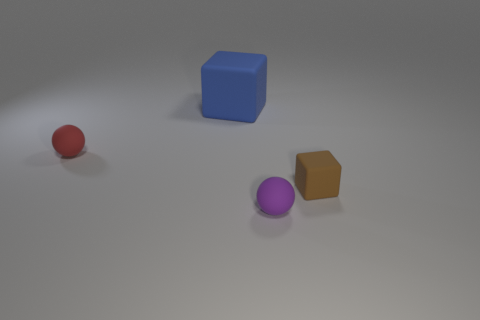Is there any other thing that is the same size as the blue rubber thing?
Make the answer very short. No. Are there any other brown things that have the same shape as the big rubber object?
Ensure brevity in your answer.  Yes. There is a sphere in front of the red rubber object; what is its size?
Offer a terse response. Small. Are there more things than blue matte blocks?
Your answer should be compact. Yes. What is the size of the cube behind the tiny object that is to the left of the large blue rubber object?
Offer a terse response. Large. What shape is the purple rubber object that is the same size as the red rubber object?
Make the answer very short. Sphere. What shape is the matte object to the right of the rubber ball in front of the small ball that is behind the tiny brown object?
Your answer should be very brief. Cube. Is the color of the cube that is to the right of the purple ball the same as the small rubber sphere that is in front of the tiny red sphere?
Your answer should be very brief. No. What number of blue rubber cubes are there?
Your response must be concise. 1. There is a small purple ball; are there any blocks right of it?
Ensure brevity in your answer.  Yes. 